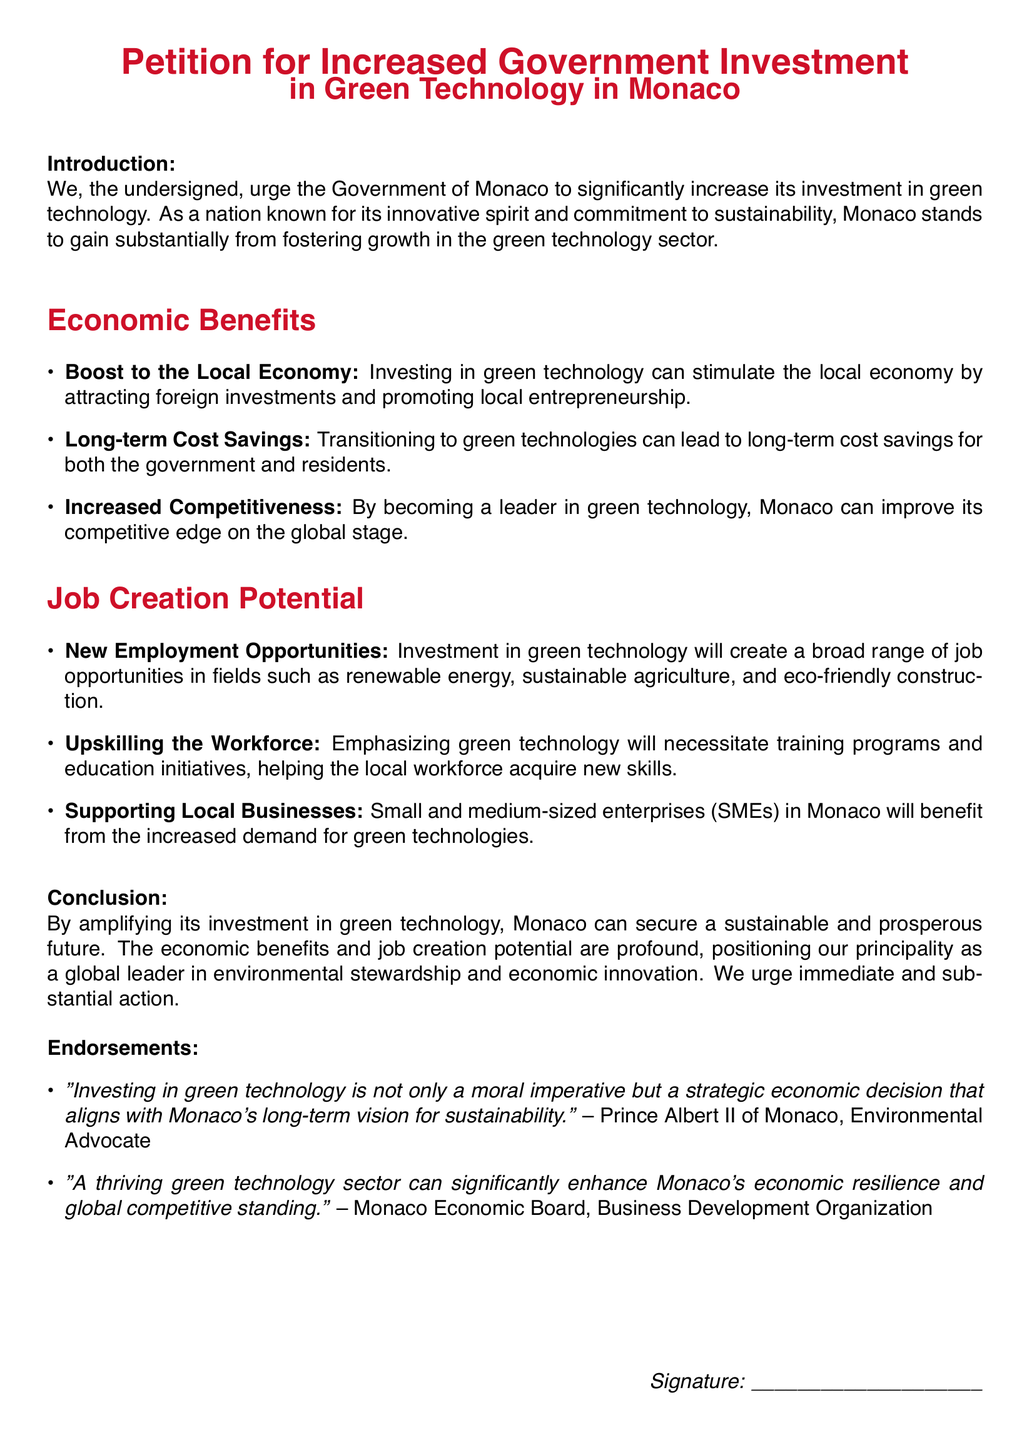What is the primary call to action in the petition? The primary call to action is for the Government of Monaco to significantly increase its investment in green technology.
Answer: increase its investment in green technology What are two economic benefits mentioned in the document? The petition lists "boost to the local economy" and "long-term cost savings" as economic benefits.
Answer: boost to the local economy, long-term cost savings Who is quoted regarding the moral imperative of investing in green technology? The quote regarding the moral imperative is attributed to Prince Albert II of Monaco, an environmental advocate.
Answer: Prince Albert II of Monaco What is one job creation potential mentioned in the document? One of the job creation potentials mentioned is "new employment opportunities."
Answer: new employment opportunities What color is used for the main title text in the document? The main title text is in the color defined as "monacored."
Answer: monacored How many overall sections are present in the petition? The petition includes three main sections: "Introduction," "Economic Benefits," and "Job Creation Potential."
Answer: three What is the aim of upskilling the workforce according to the document? The aim is to help the local workforce acquire new skills.
Answer: help the local workforce acquire new skills What organization is associated with the concept of enhancing Monaco's economic resilience? The Monaco Economic Board is associated with enhancing Monaco's economic resilience.
Answer: Monaco Economic Board 